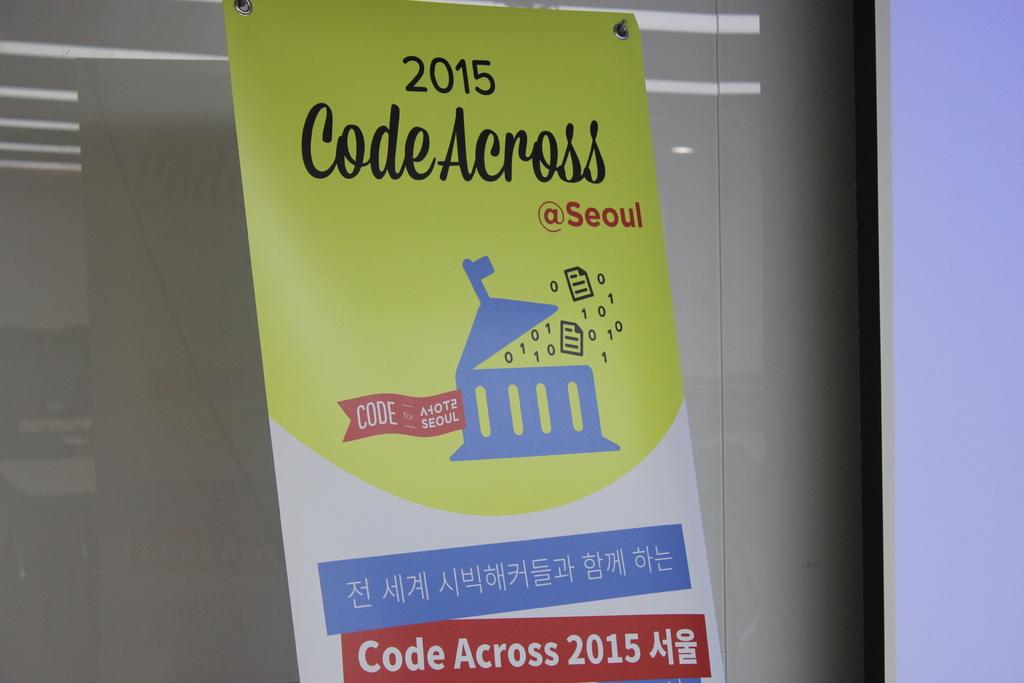<image>
Give a short and clear explanation of the subsequent image. a yellow blue red and white flyer for 2015 code across 